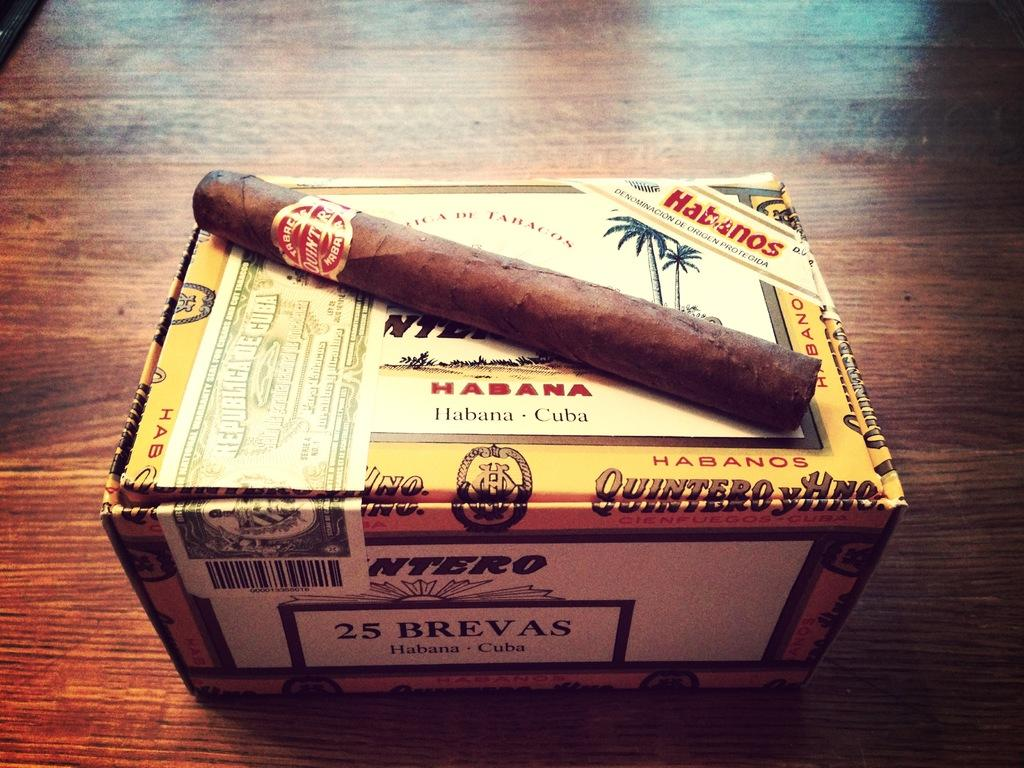<image>
Offer a succinct explanation of the picture presented. A rolled cigar is sitting on a box of Habana cigars from Cuba. 